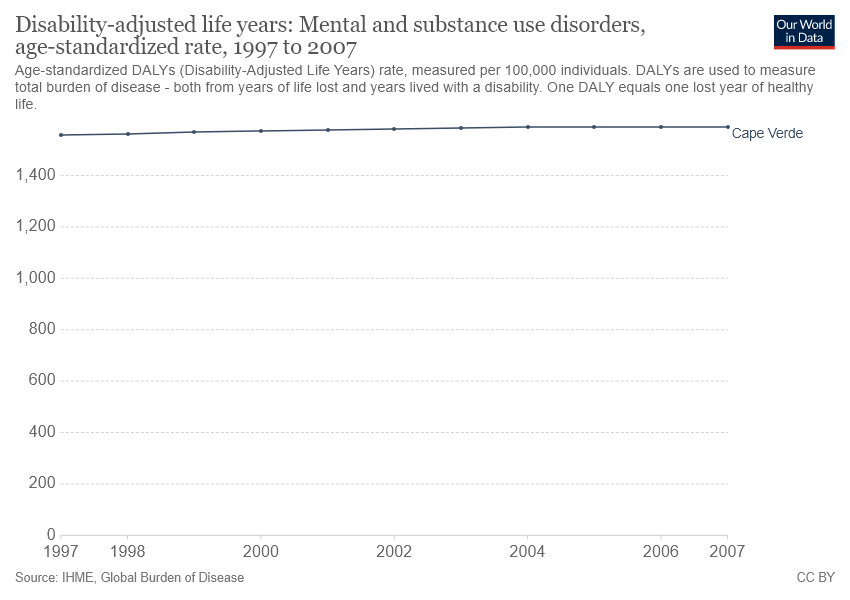Identify some key points in this picture. The presented data is from the country of Cape Verde. The value of Disability-adjusted life years in Cape Verde was consistently above 1400 from 1997 to 2007. 